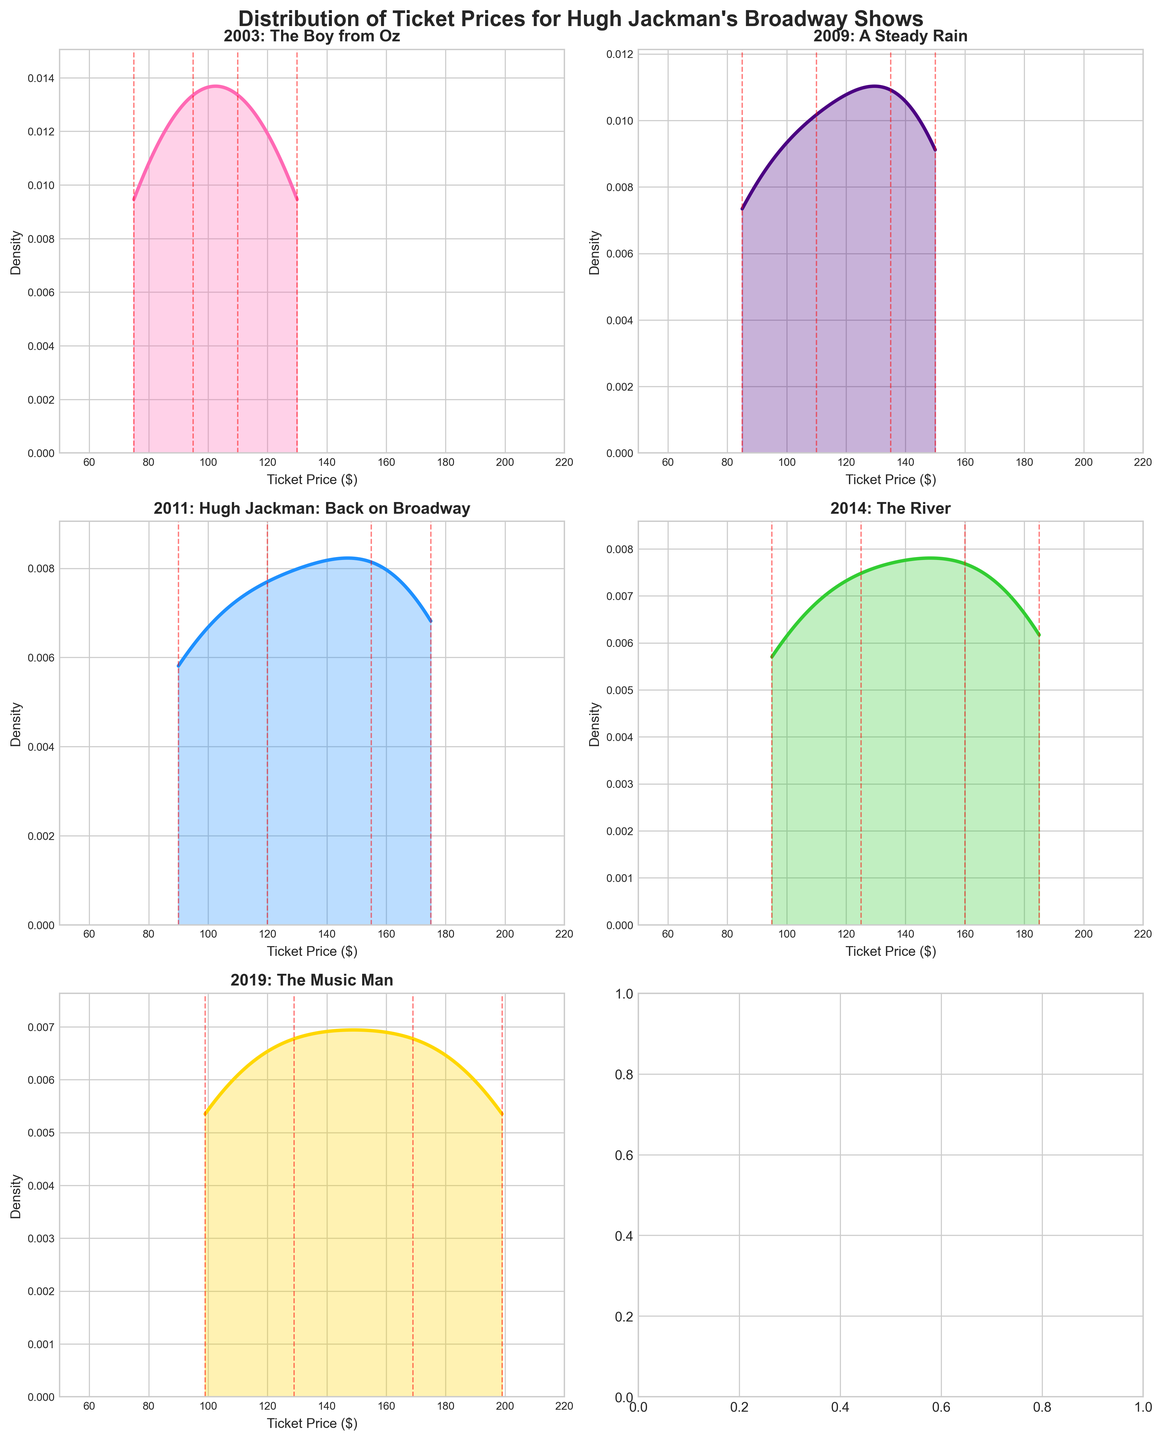Which year has the highest peak in ticket price density? The highest peak can be found by comparing the density peaks of each year's subplot. The peak density for 2011 ("Hugh Jackman: Back on Broadway") is the highest.
Answer: 2011 What is the show title for the year 2009? The show title for each year is displayed in the subplot title. The title for 2009 is "A Steady Rain."
Answer: A Steady Rain Which year has the widest range of ticket prices? The range of ticket prices can be seen by looking at the span of the x-axis in each subplot. The year 2019 ("The Music Man") has the widest range of ticket prices from $99 to $199.
Answer: 2019 How many ticket price points are there for the year 2014? Red dashed lines represent the ticket price points. For the year 2014, you can count four red lines.
Answer: 4 What is the maximum ticket price in 2003? The maximum ticket price in each subplot can be found by checking the highest red dashed line. For 2003, the highest price is $130.
Answer: $130 Which years have the ticket price above $150? By examining each subplot, you can see that the years with ticket prices above $150 are 2009, 2011, 2014, and 2019.
Answer: 2009, 2011, 2014, 2019 In which year is the ticket price density more evenly spread across a range? The even spread of density can be observed by looking at how flat and wide the density curve is. The year 2014 ("The River") shows a more evenly spread density across a broader range.
Answer: 2014 Which show has the lowest minimum ticket price, and what is that price? By checking the lowest red dashed line in each subplot, "The Boy from Oz" in 2003 has the lowest minimum ticket price at $75.
Answer: The Boy from Oz, $75 